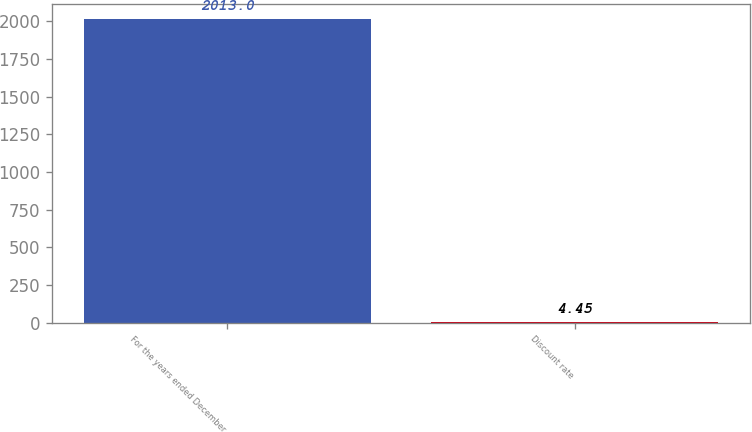Convert chart. <chart><loc_0><loc_0><loc_500><loc_500><bar_chart><fcel>For the years ended December<fcel>Discount rate<nl><fcel>2013<fcel>4.45<nl></chart> 